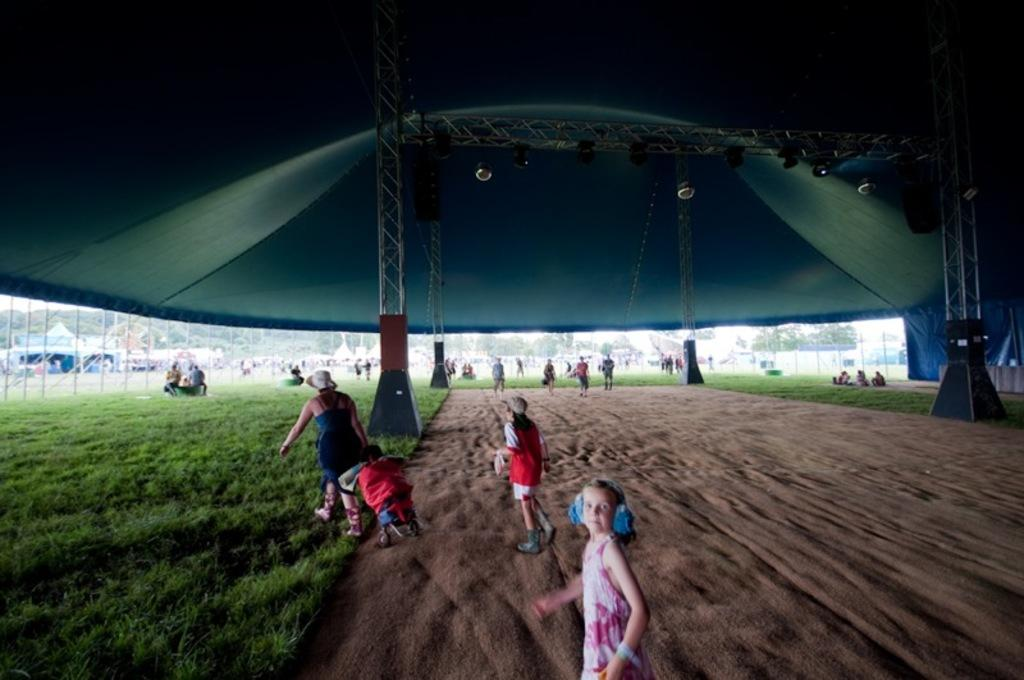How many people are in the image? There is a group of people in the image, but the exact number is not specified. What are the people in the image doing? Some people are sitting on the ground, and some are standing. What structures can be seen in the image? There is a fence and pillars in the image. What type of temporary shelters are present in the image? There are tents in the image. What can be seen in the background of the image? There are trees in the background of the image. What type of straw is being used by the people in the image? There is no straw visible or mentioned in the image. How many haircuts are being given in the image? There is no mention of haircuts or any related activity in the image. 